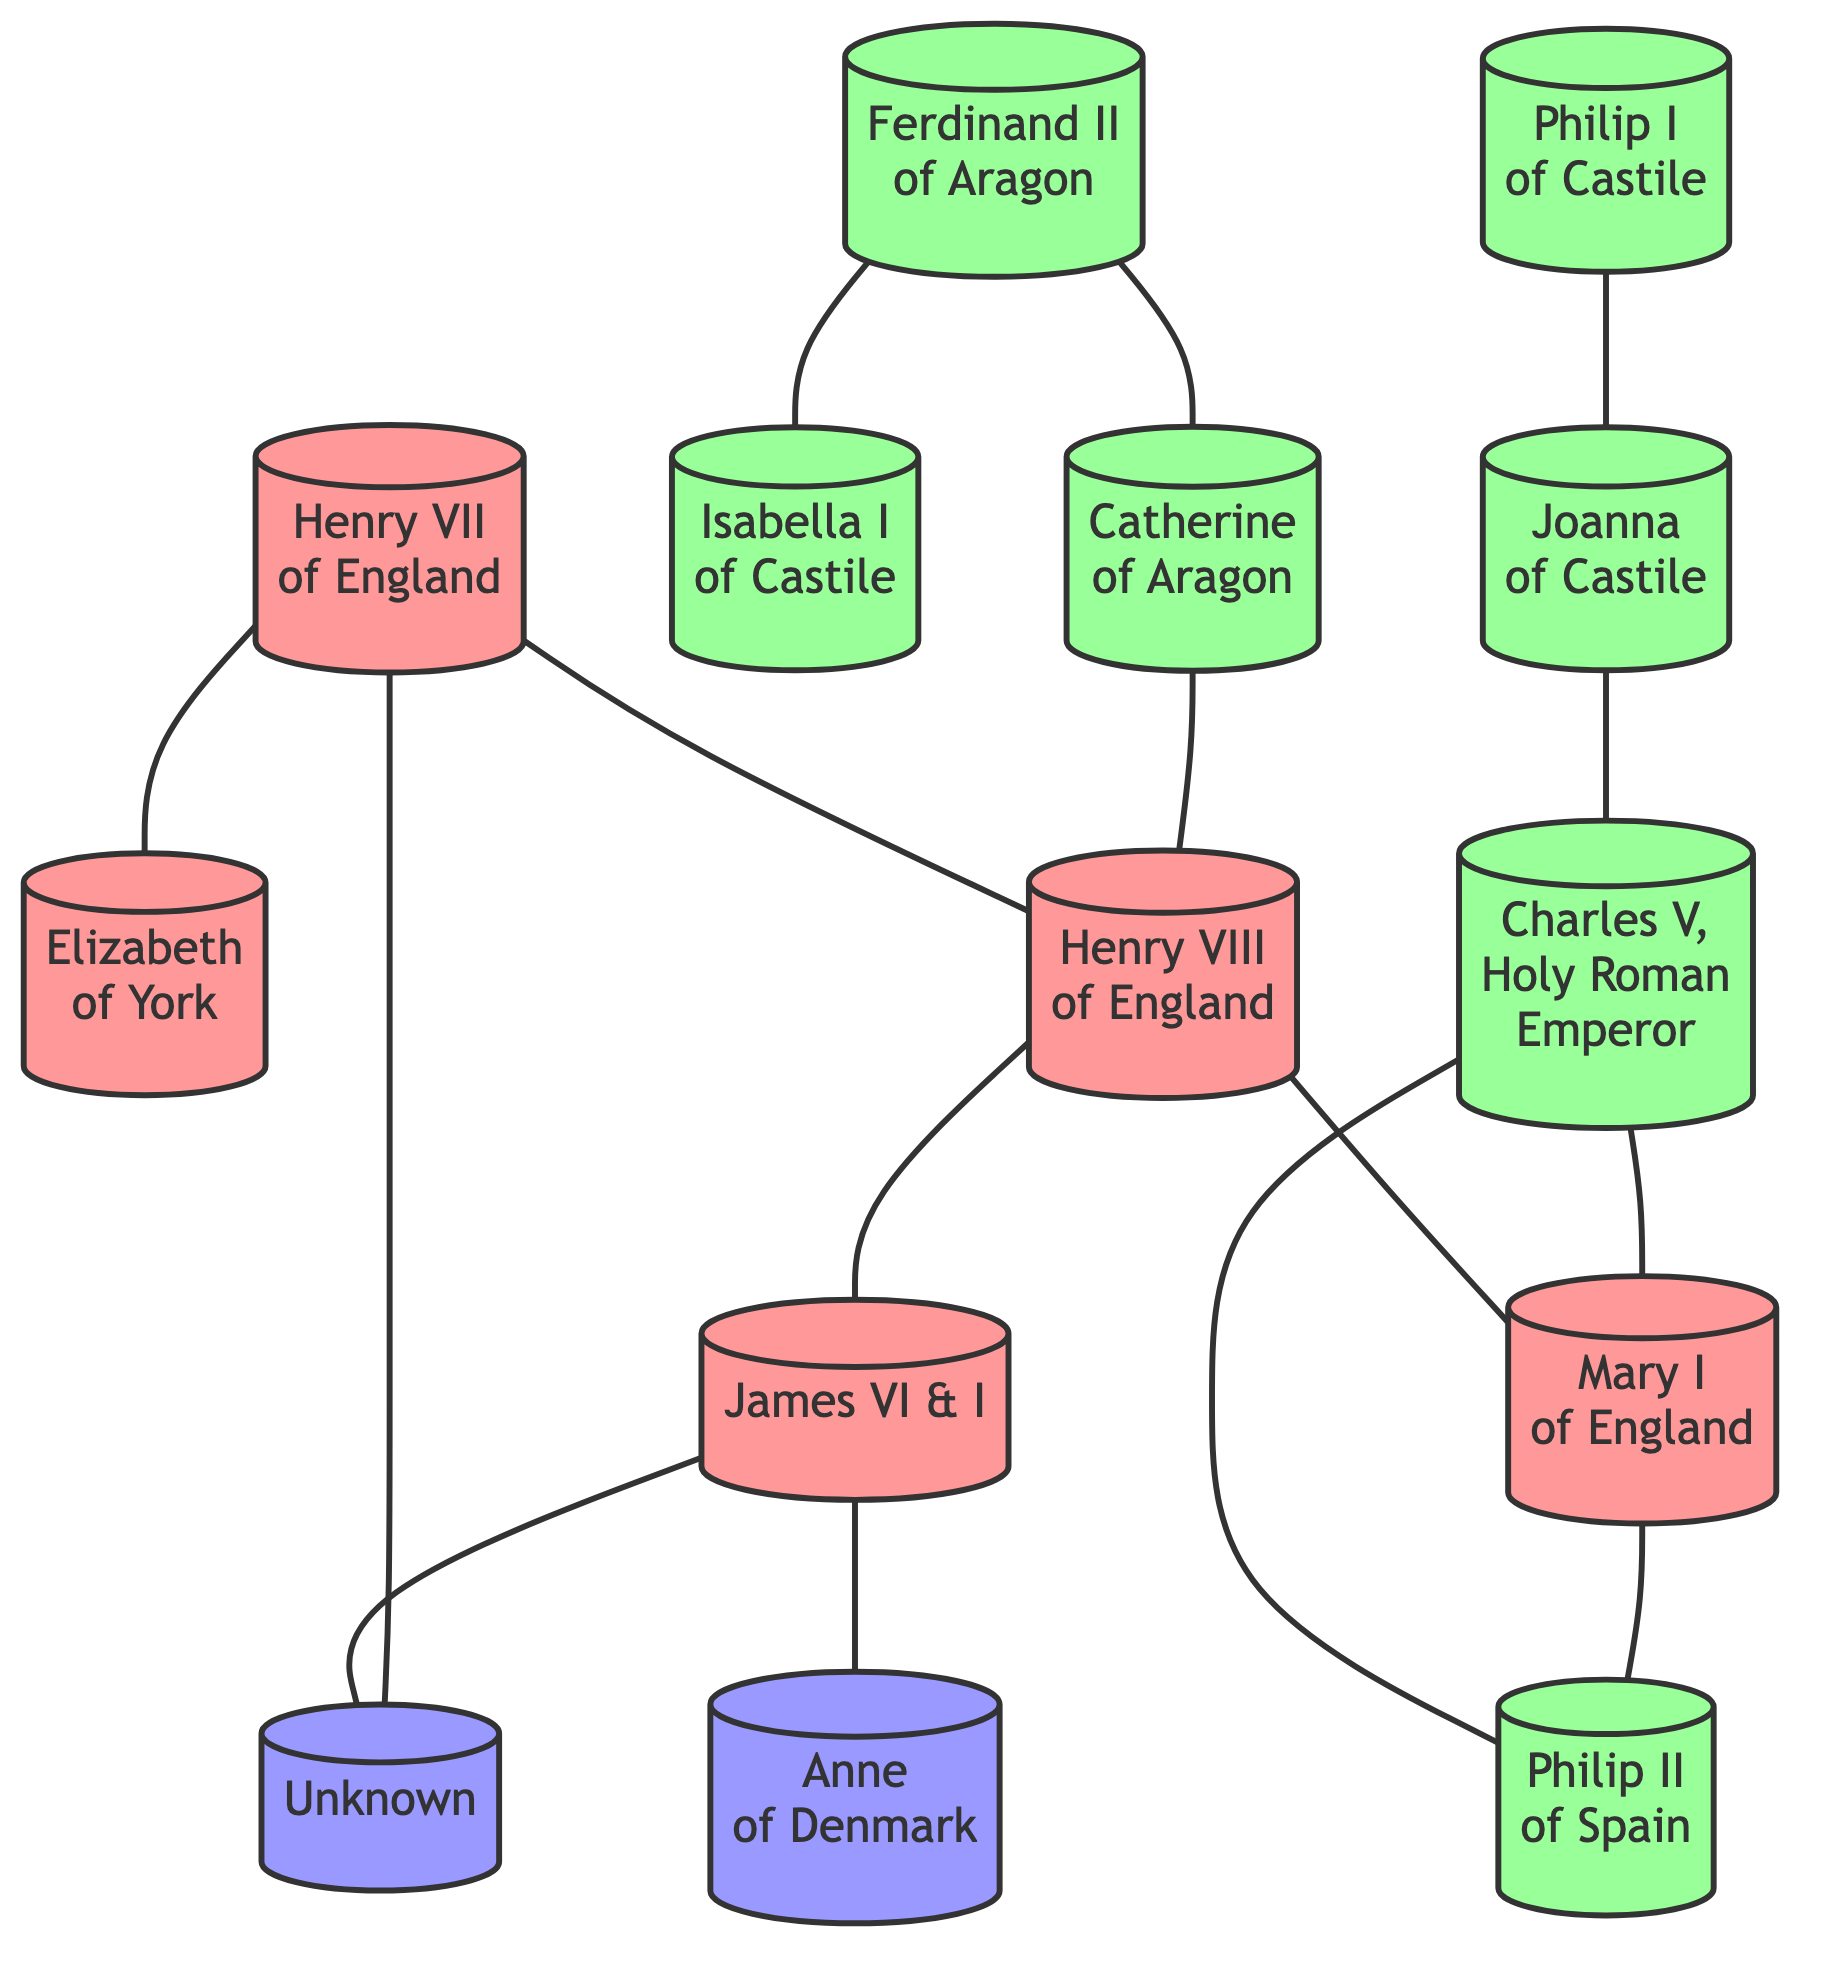What is the total number of nodes in the diagram? The diagram contains 13 nodes as listed in the data under the "nodes" section: Henry VII of England, Elizabeth of York, Ferdinand II of Aragon, Isabella I of Castile, Philip I of Castile, Joanna of Castile, Charles V, Holy Roman Emperor, Mary I of England, Philip II of Spain, Catherine of Aragon, Henry VIII of England, James VI of Scotland and I of England, and Anne of Denmark.
Answer: 13 Who is the spouse of Joanna of Castile? Joanna of Castile is connected to Philip I of Castile based on the edge provided in the data indicating a direct relationship between them.
Answer: Philip I of Castile How many edges are connected to Henry VIII? By examining the edges connected to Henry VIII, we find he has three connections: one to Catherine of Aragon, one to Mary I of England, and one to James VI and I. Therefore, he is connected to three edges.
Answer: 3 Which two individuals are connected by a link to both Mary I of England and Philip II of Spain? The connections show that Mary I of England is linked to both Charles V, Holy Roman Emperor, and Philip II of Spain. Analyzing the diagram, we see that Charles V is directly linked to Mary I, who in turn is connected to Philip II. Thus, the two individuals asked about are Charles V and Philip II.
Answer: Charles V, Philip II Which royal is both a parent and a spouse to Mary I of England? Based on the edges, Mary I of England is connected to both Henry VIII, who is her father, and Philip II of Spain, who is her spouse. This means Henry VIII is the royal that serves as both parent and spouse.
Answer: Henry VIII How many nodes in the diagram are related to the Spanish royalty? The nodes associated with Spanish royalty are Ferdinand II of Aragon, Isabella I of Castile, Joanna of Castile, Philip I of Castile, Charles V, Holy Roman Emperor, Philip II of Spain, and Catherine of Aragon. There are seven in total.
Answer: 7 What is the connection type between Henry VII and Elizabeth of York? The edge connecting Henry VII and Elizabeth of York defines their relationship as a marriage, as indicated by the direct link in the diagram. Thus, the connection type is a marital relationship.
Answer: Marital relationship Which individual is connected to both Ferdinand II of Aragon and Henry VIII? The diagram shows a connection from Ferdinand II of Aragon to Catherine of Aragon, then Catherine is also linked to Henry VIII. Therefore, the individual linked to both is Catherine of Aragon.
Answer: Catherine of Aragon 